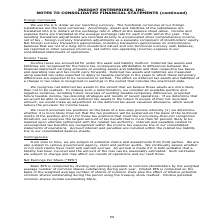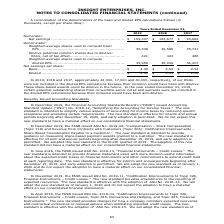According to Insight Enterprises's financial document, How is Basic EPS computed? by dividing net earnings available to common stockholders by the weighted average number of common shares outstanding during each year.. The document states: "Basic EPS is computed by dividing net earnings available to common stockholders by the weighted average number of common shares outstanding during eac..." Also, How is Diluted EPS computed? on the basis of the weighted average number of shares of common stock plus the effect of dilutive potential common shares outstanding during the period using the treasury stock method. The document states: "tanding during each year. Diluted EPS is computed on the basis of the weighted average number of shares of common stock plus the effect of dilutive po..." Also, How much RSUs were not included in the diluted EPS calculations in 2019, 2018 and 2017 respectively? The document contains multiple relevant values: 42,000, 17,000, 40,000. From the document: "In 2019, 2018 and 2017, approximately 42,000, 17,000 and 40,000, respectively, of our RSUs were not included in the diluted EPS calculations bec , 201..." Also, can you calculate: What is the change in Net earnings between 2018 and 2019? Based on the calculation: 159,407-163,677, the result is -4270 (in thousands). This is based on the information: "............................................... $ 159,407 $ 163,677 $ 90,683 Denominator: Weighted-average shares used to compute basic EPS.................. ..................................... $ 15..." The key data points involved are: 159,407, 163,677. Also, can you calculate: What is the change in Weighted-average shares used to compute basic EPS from 2018 and 2019? Based on the calculation: 35,538-35,586, the result is -48 (in thousands). This is based on the information: ".......................................... 35,538 35,586 35,741 Dilutive potential common shares due to dilutive: RSUs, net of tax effect................... .............................................." The key data points involved are: 35,538, 35,586. Also, can you calculate: What is the average Net earnings for 2018 and 2019? To answer this question, I need to perform calculations using the financial data. The calculation is: (159,407+163,677) / 2, which equals 161542 (in thousands). This is based on the information: "............................................... $ 159,407 $ 163,677 $ 90,683 Denominator: Weighted-average shares used to compute basic EPS.................. ..................................... $ 15..." The key data points involved are: 159,407, 163,677. 